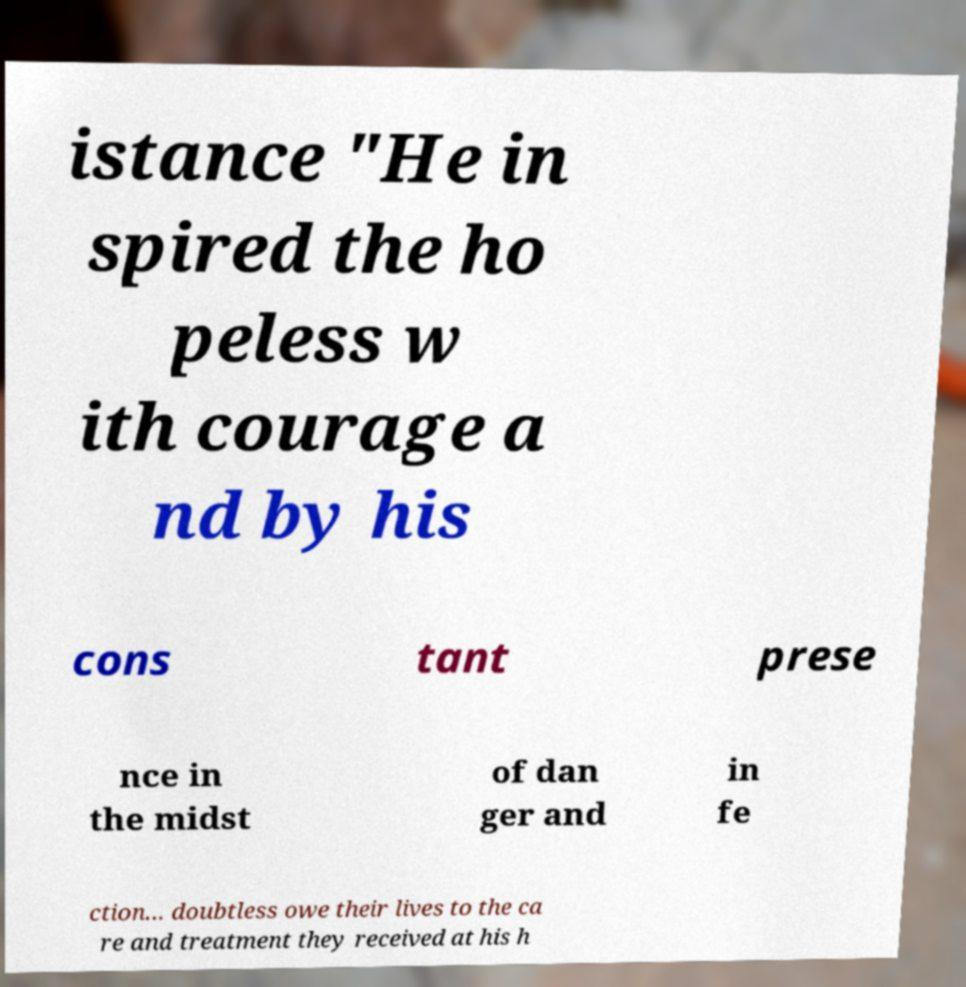What messages or text are displayed in this image? I need them in a readable, typed format. istance "He in spired the ho peless w ith courage a nd by his cons tant prese nce in the midst of dan ger and in fe ction... doubtless owe their lives to the ca re and treatment they received at his h 